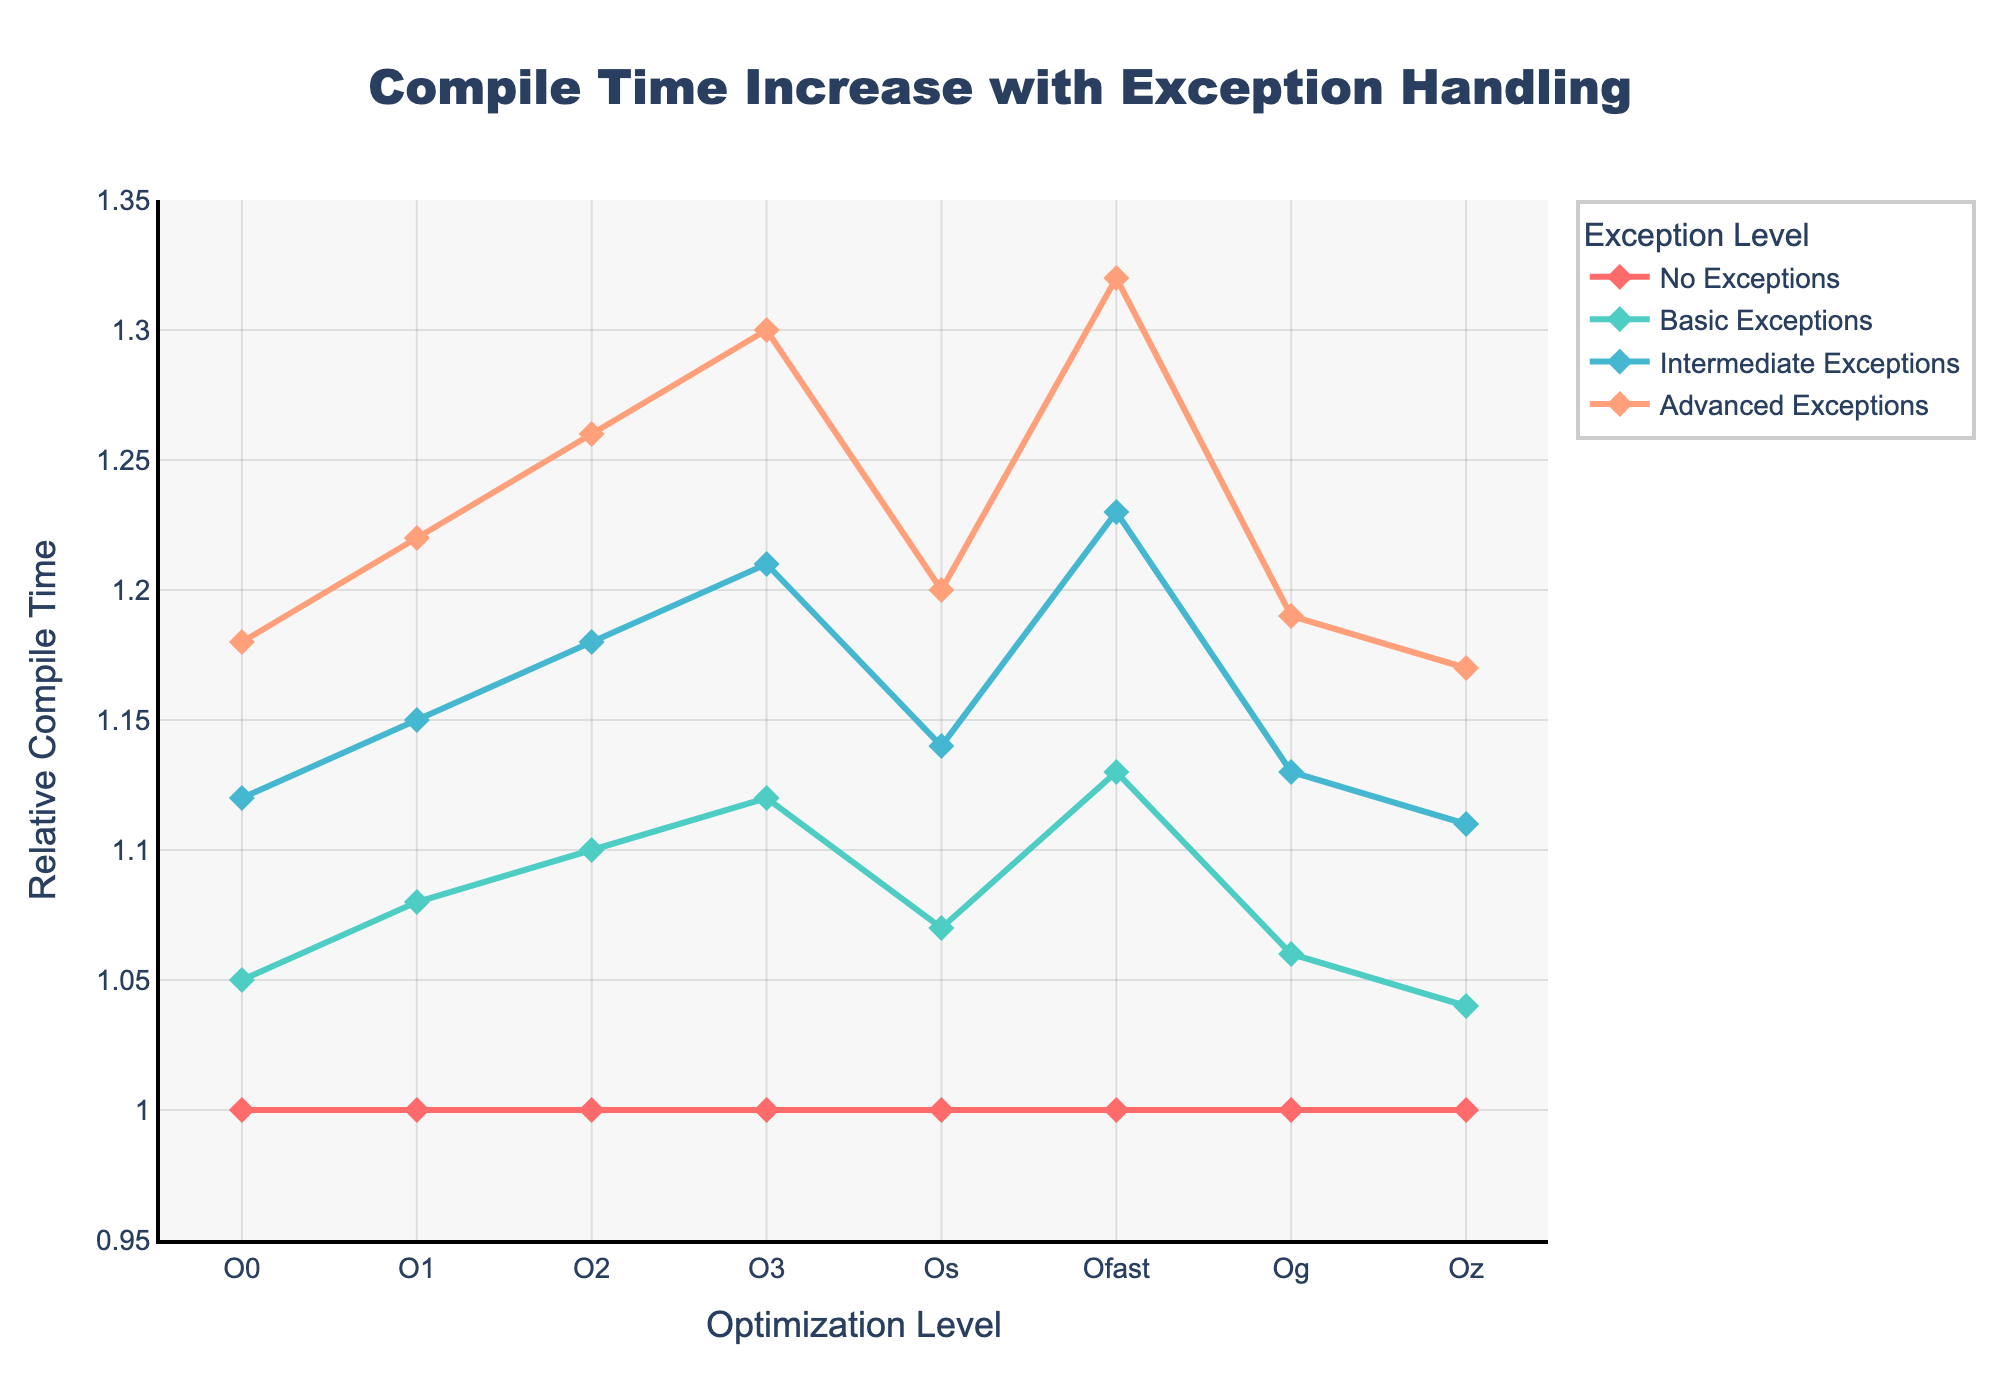What is the relative compile time for Basic Exceptions at optimization level O1? Locate the line representing "Basic Exceptions," which is colored in a distinct shade. Find its point at the optimization level "O1" and read the corresponding y-value.
Answer: 1.08 Which optimization level shows the highest relative compile time for Advanced Exceptions? Observe the "Advanced Exceptions" line and identify the peak y-value. Track it back to the x-axis to find the corresponding optimization level.
Answer: Ofast How does the compile time for Intermediate Exceptions change from O0 to O3? Find the y-values of "Intermediate Exceptions" at "O0" and "O3". Calculate the difference by subtracting the compile time at "O0" from that at "O3".
Answer: 0.09 (1.21 - 1.12) What is the average compile time increase for Advanced Exceptions over all optimization levels? Sum the y-values for "Advanced Exceptions" across all optimization levels and then divide by the total number of levels (8).
Answer: 1.23 Compare the compile times at optimization level O2 for Basic and Intermediate Exceptions. Which one is higher and by how much? Locate the points for "Basic Exceptions" and "Intermediate Exceptions" at "O2" and note the y-values. Subtract the Basic's y-value from the Intermediate's y-value.
Answer: Intermediate Exceptions, by 0.08 (1.18 - 1.10) Which exception handling implementation shows the least variation across all optimization levels? Visually inspect the lines for "No Exceptions," "Basic Exceptions," "Intermediate Exceptions," and "Advanced Exceptions" for the smallest range (difference between the highest and lowest points).
Answer: No Exceptions What is the difference in compile time for Advanced Exceptions between optimization levels O0 and O3? Identify and subtract the y-values at "O0" from "O3" for the "Advanced Exceptions" line.
Answer: 0.12 (1.30 - 1.18) For Basic Exceptions, how much does the compile time increase from optimization level Os to Og? Locate the y-values for "Basic Exceptions" at "Os" and "Og". Subtract the compile time at "Os" from that at "Og".
Answer: -0.01 (1.06 - 1.07) Which optimization level shows the smallest relative compile time increase for any exception handling implementation compared to "No Exceptions"? Visually or by comparison, find the points for all exception handling levels at each optimization level and find the smallest value above "1.0".
Answer: Oz (1.04 for Basic Exceptions) How much does the compile time for Advanced Exceptions increase, on average, from O0 to all other optimization levels? Calculate the differences between "Advanced Exceptions" at "O0" and each of the other optimization levels. Sum these differences and divide by the number of other levels (7).
Answer: 0.135 ([(1.22-1.18) + (1.26-1.18) + (1.30-1.18) + (1.20-1.18) + (1.32-1.18) + (1.19-1.18) + (1.17-1.18)] / 7) 